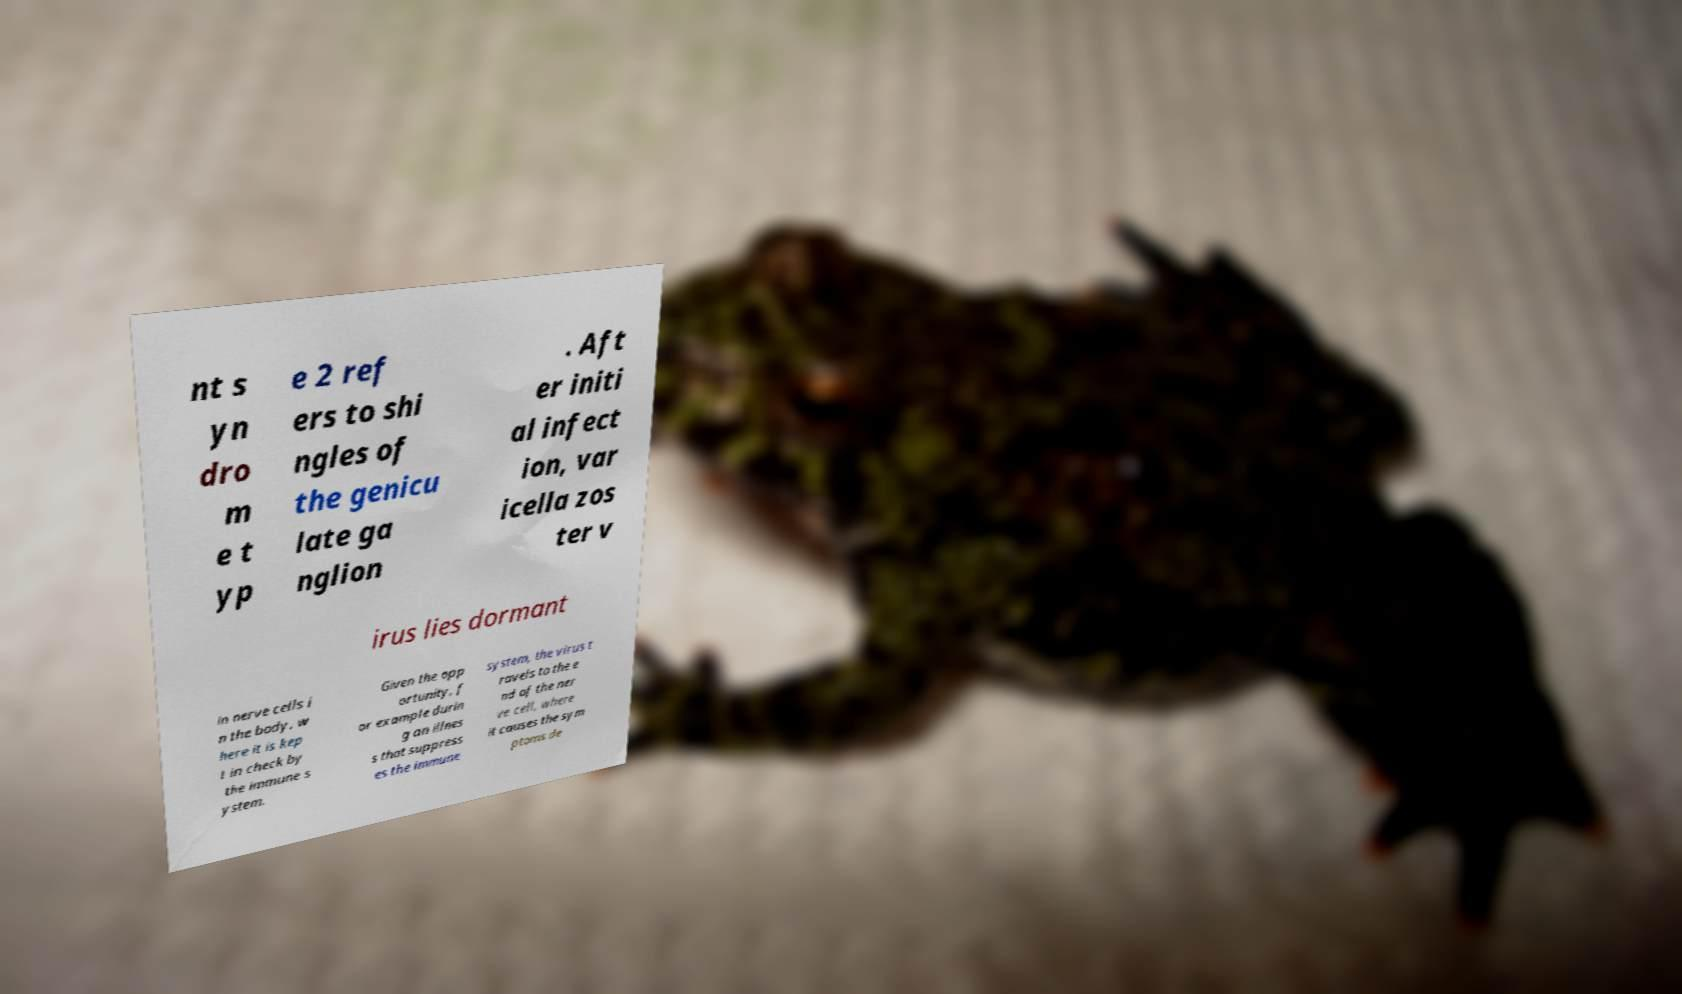Could you extract and type out the text from this image? nt s yn dro m e t yp e 2 ref ers to shi ngles of the genicu late ga nglion . Aft er initi al infect ion, var icella zos ter v irus lies dormant in nerve cells i n the body, w here it is kep t in check by the immune s ystem. Given the opp ortunity, f or example durin g an illnes s that suppress es the immune system, the virus t ravels to the e nd of the ner ve cell, where it causes the sym ptoms de 